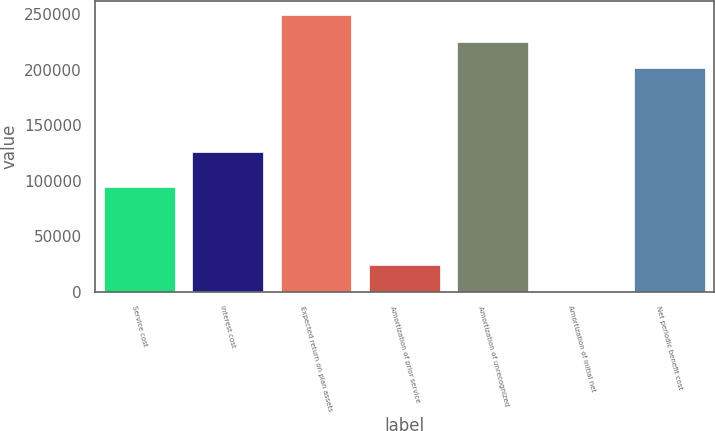<chart> <loc_0><loc_0><loc_500><loc_500><bar_chart><fcel>Service cost<fcel>Interest cost<fcel>Expected return on plan assets<fcel>Amortization of prior service<fcel>Amortization of unrecognized<fcel>Amortization of initial net<fcel>Net periodic benefit cost<nl><fcel>94356<fcel>126131<fcel>249421<fcel>23969.9<fcel>225469<fcel>18<fcel>201517<nl></chart> 